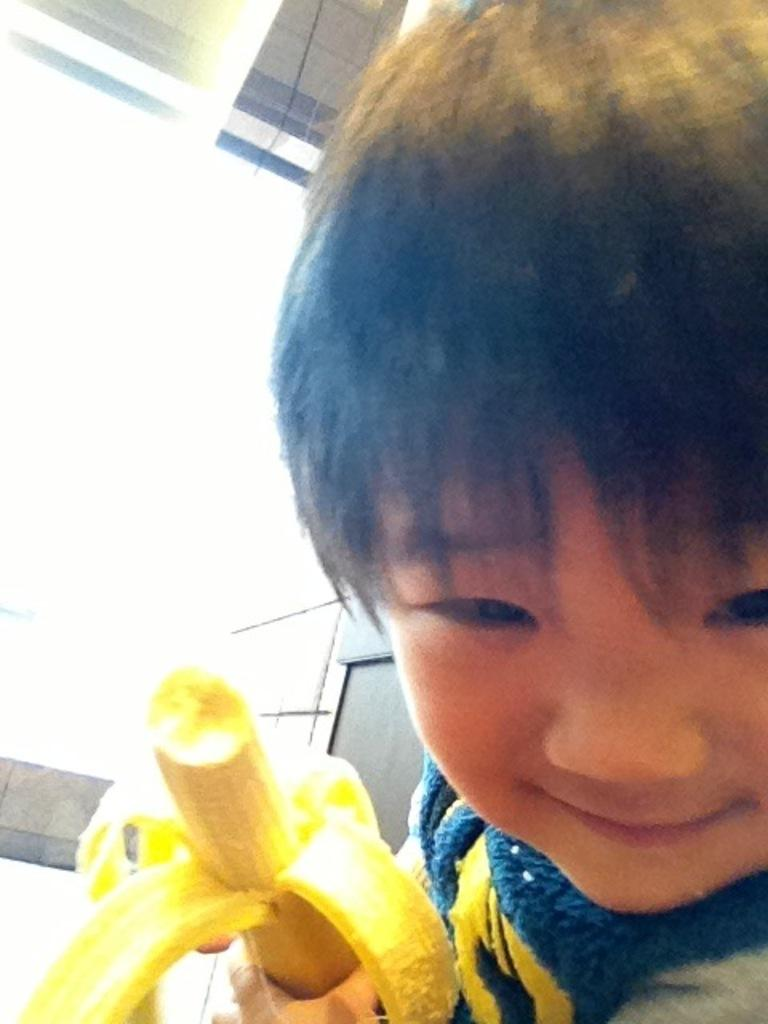Who is present on the right side of the image? There is a person on the right side of the image. What is the person holding in the image? The person is holding a banana. What is the person's facial expression in the image? The person is smiling. What else can be seen in the background of the image? There are other objects visible in the background of the image. What type of haircut does the maid have in the image? There is no maid present in the image, and therefore no haircut to describe. 